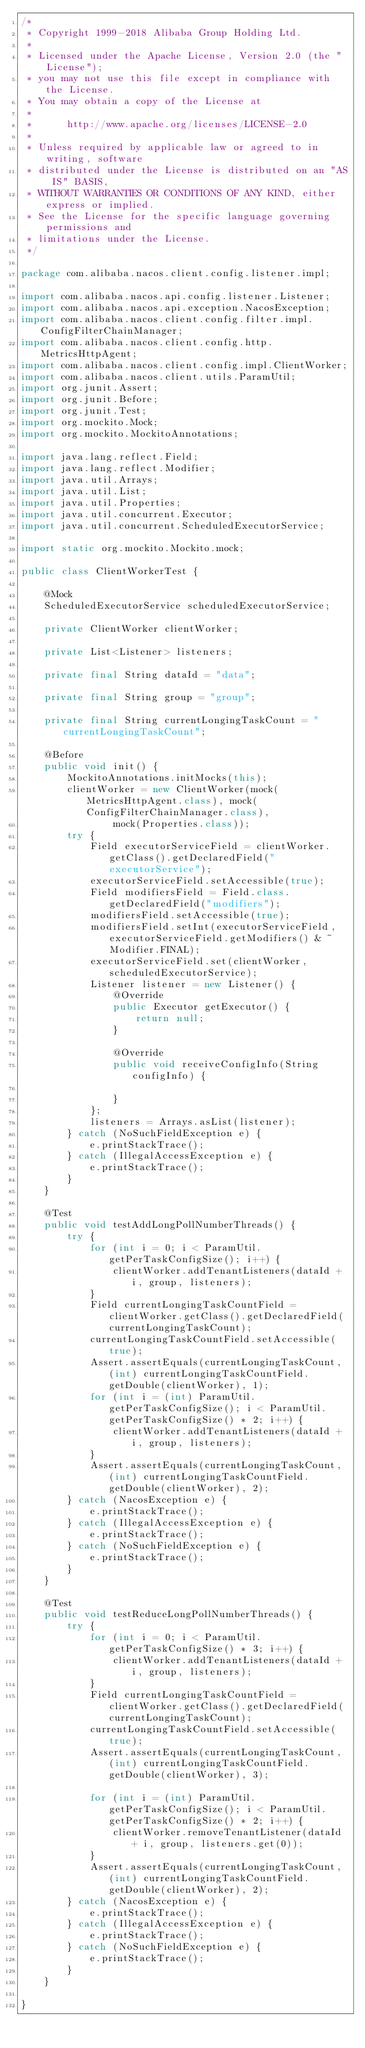<code> <loc_0><loc_0><loc_500><loc_500><_Java_>/*
 * Copyright 1999-2018 Alibaba Group Holding Ltd.
 *
 * Licensed under the Apache License, Version 2.0 (the "License");
 * you may not use this file except in compliance with the License.
 * You may obtain a copy of the License at
 *
 *      http://www.apache.org/licenses/LICENSE-2.0
 *
 * Unless required by applicable law or agreed to in writing, software
 * distributed under the License is distributed on an "AS IS" BASIS,
 * WITHOUT WARRANTIES OR CONDITIONS OF ANY KIND, either express or implied.
 * See the License for the specific language governing permissions and
 * limitations under the License.
 */

package com.alibaba.nacos.client.config.listener.impl;

import com.alibaba.nacos.api.config.listener.Listener;
import com.alibaba.nacos.api.exception.NacosException;
import com.alibaba.nacos.client.config.filter.impl.ConfigFilterChainManager;
import com.alibaba.nacos.client.config.http.MetricsHttpAgent;
import com.alibaba.nacos.client.config.impl.ClientWorker;
import com.alibaba.nacos.client.utils.ParamUtil;
import org.junit.Assert;
import org.junit.Before;
import org.junit.Test;
import org.mockito.Mock;
import org.mockito.MockitoAnnotations;

import java.lang.reflect.Field;
import java.lang.reflect.Modifier;
import java.util.Arrays;
import java.util.List;
import java.util.Properties;
import java.util.concurrent.Executor;
import java.util.concurrent.ScheduledExecutorService;

import static org.mockito.Mockito.mock;

public class ClientWorkerTest {
    
    @Mock
    ScheduledExecutorService scheduledExecutorService;
    
    private ClientWorker clientWorker;
    
    private List<Listener> listeners;
    
    private final String dataId = "data";
    
    private final String group = "group";
    
    private final String currentLongingTaskCount = "currentLongingTaskCount";
    
    @Before
    public void init() {
        MockitoAnnotations.initMocks(this);
        clientWorker = new ClientWorker(mock(MetricsHttpAgent.class), mock(ConfigFilterChainManager.class),
                mock(Properties.class));
        try {
            Field executorServiceField = clientWorker.getClass().getDeclaredField("executorService");
            executorServiceField.setAccessible(true);
            Field modifiersField = Field.class.getDeclaredField("modifiers");
            modifiersField.setAccessible(true);
            modifiersField.setInt(executorServiceField, executorServiceField.getModifiers() & ~Modifier.FINAL);
            executorServiceField.set(clientWorker, scheduledExecutorService);
            Listener listener = new Listener() {
                @Override
                public Executor getExecutor() {
                    return null;
                }
                
                @Override
                public void receiveConfigInfo(String configInfo) {
                
                }
            };
            listeners = Arrays.asList(listener);
        } catch (NoSuchFieldException e) {
            e.printStackTrace();
        } catch (IllegalAccessException e) {
            e.printStackTrace();
        }
    }
    
    @Test
    public void testAddLongPollNumberThreads() {
        try {
            for (int i = 0; i < ParamUtil.getPerTaskConfigSize(); i++) {
                clientWorker.addTenantListeners(dataId + i, group, listeners);
            }
            Field currentLongingTaskCountField = clientWorker.getClass().getDeclaredField(currentLongingTaskCount);
            currentLongingTaskCountField.setAccessible(true);
            Assert.assertEquals(currentLongingTaskCount, (int) currentLongingTaskCountField.getDouble(clientWorker), 1);
            for (int i = (int) ParamUtil.getPerTaskConfigSize(); i < ParamUtil.getPerTaskConfigSize() * 2; i++) {
                clientWorker.addTenantListeners(dataId + i, group, listeners);
            }
            Assert.assertEquals(currentLongingTaskCount, (int) currentLongingTaskCountField.getDouble(clientWorker), 2);
        } catch (NacosException e) {
            e.printStackTrace();
        } catch (IllegalAccessException e) {
            e.printStackTrace();
        } catch (NoSuchFieldException e) {
            e.printStackTrace();
        }
    }
    
    @Test
    public void testReduceLongPollNumberThreads() {
        try {
            for (int i = 0; i < ParamUtil.getPerTaskConfigSize() * 3; i++) {
                clientWorker.addTenantListeners(dataId + i, group, listeners);
            }
            Field currentLongingTaskCountField = clientWorker.getClass().getDeclaredField(currentLongingTaskCount);
            currentLongingTaskCountField.setAccessible(true);
            Assert.assertEquals(currentLongingTaskCount, (int) currentLongingTaskCountField.getDouble(clientWorker), 3);
            
            for (int i = (int) ParamUtil.getPerTaskConfigSize(); i < ParamUtil.getPerTaskConfigSize() * 2; i++) {
                clientWorker.removeTenantListener(dataId + i, group, listeners.get(0));
            }
            Assert.assertEquals(currentLongingTaskCount, (int) currentLongingTaskCountField.getDouble(clientWorker), 2);
        } catch (NacosException e) {
            e.printStackTrace();
        } catch (IllegalAccessException e) {
            e.printStackTrace();
        } catch (NoSuchFieldException e) {
            e.printStackTrace();
        }
    }
    
}
</code> 